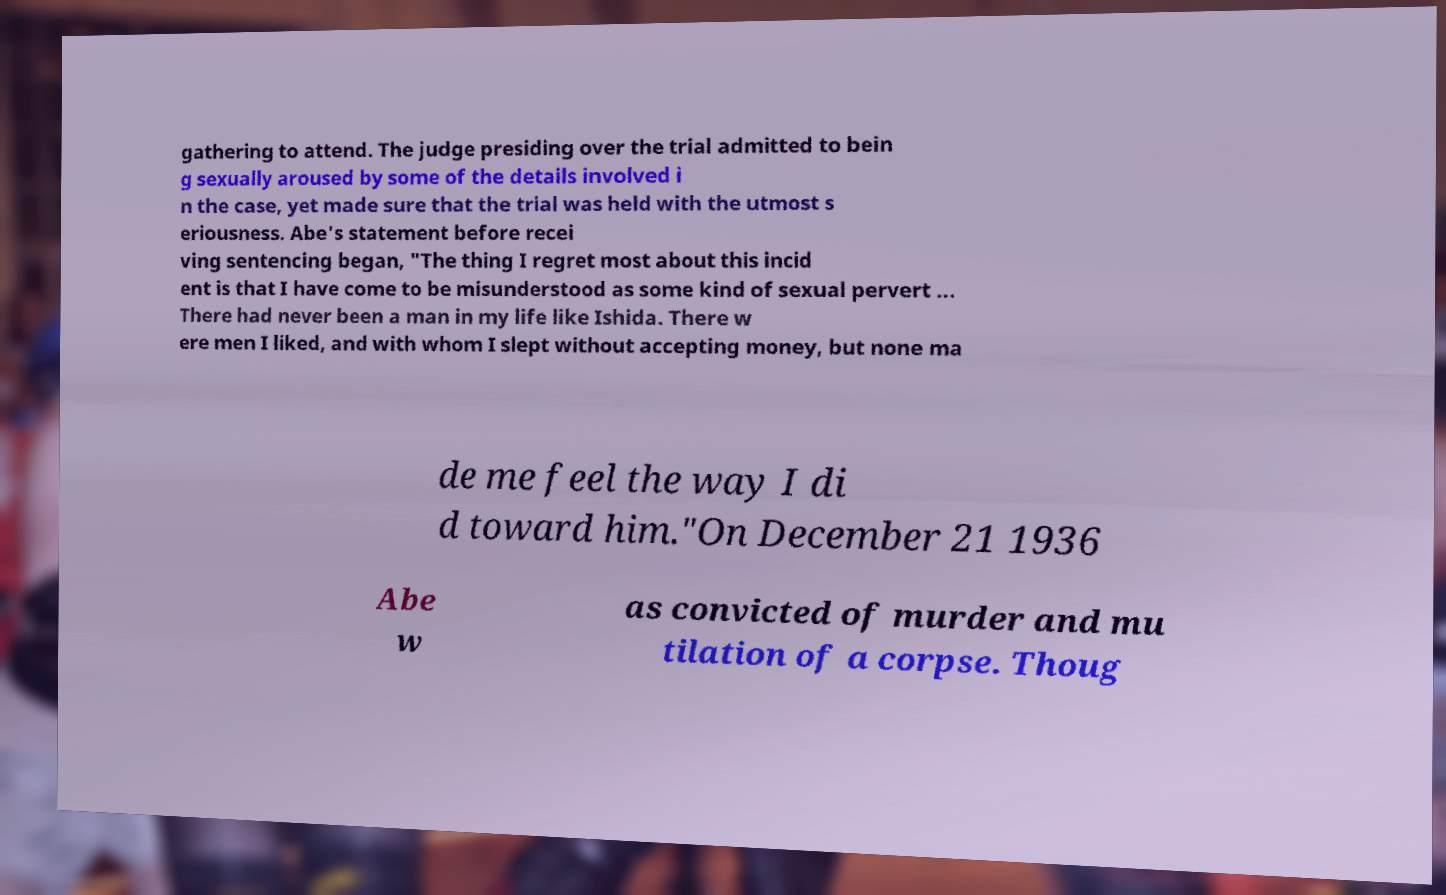Can you read and provide the text displayed in the image?This photo seems to have some interesting text. Can you extract and type it out for me? gathering to attend. The judge presiding over the trial admitted to bein g sexually aroused by some of the details involved i n the case, yet made sure that the trial was held with the utmost s eriousness. Abe's statement before recei ving sentencing began, "The thing I regret most about this incid ent is that I have come to be misunderstood as some kind of sexual pervert ... There had never been a man in my life like Ishida. There w ere men I liked, and with whom I slept without accepting money, but none ma de me feel the way I di d toward him."On December 21 1936 Abe w as convicted of murder and mu tilation of a corpse. Thoug 